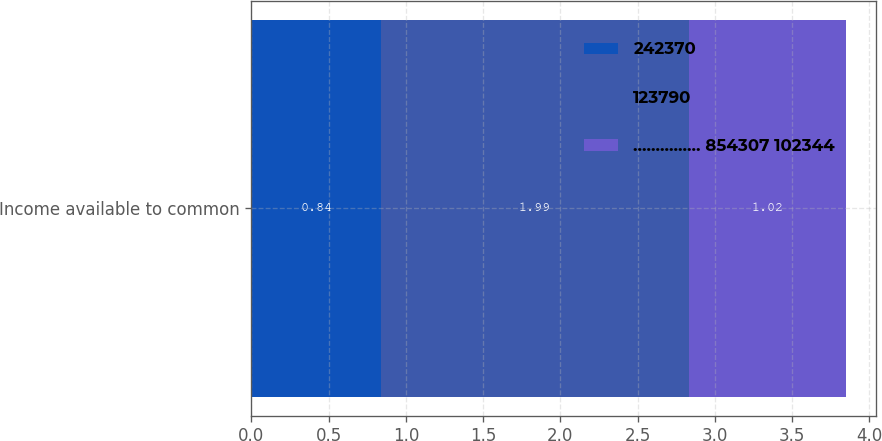Convert chart to OTSL. <chart><loc_0><loc_0><loc_500><loc_500><stacked_bar_chart><ecel><fcel>Income available to common<nl><fcel>242370<fcel>0.84<nl><fcel>123790<fcel>1.99<nl><fcel>............... 854307 102344<fcel>1.02<nl></chart> 